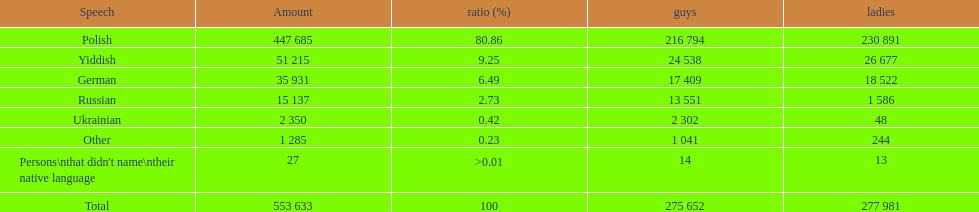How many speakers (of any language) are represented on the table ? 553 633. 